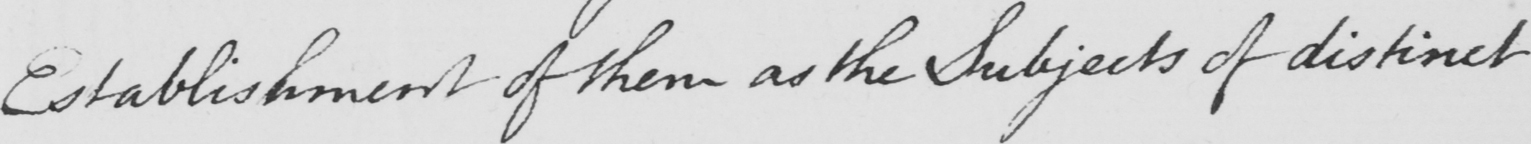What text is written in this handwritten line? Establishment of them as the Subjects of distinct 